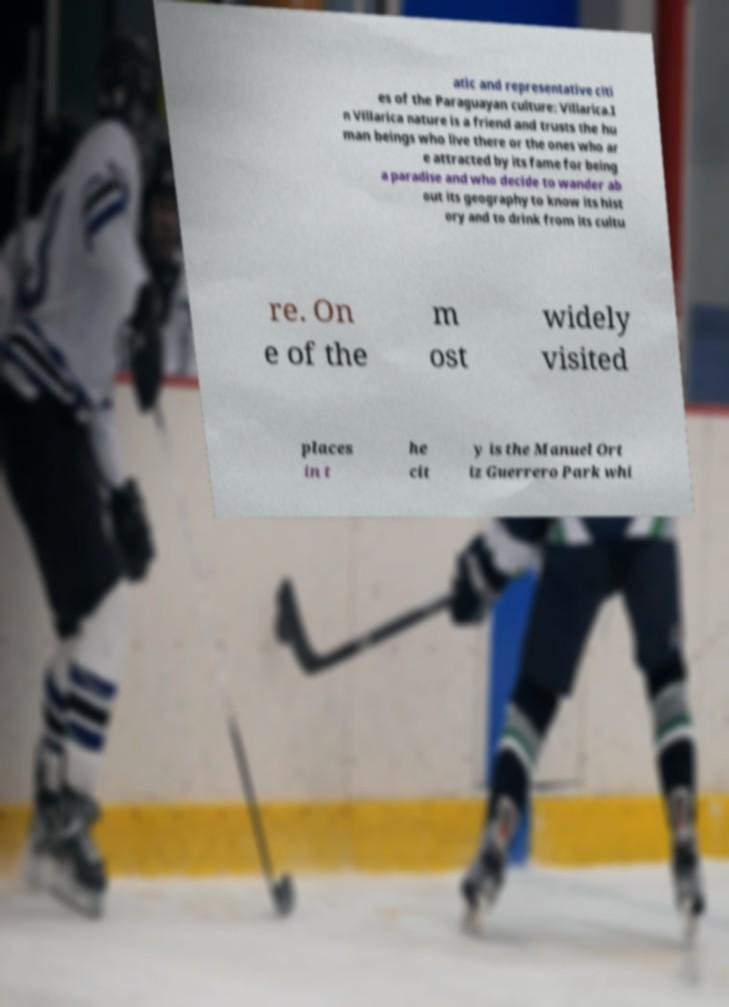For documentation purposes, I need the text within this image transcribed. Could you provide that? atic and representative citi es of the Paraguayan culture: Villarica.I n Villarica nature is a friend and trusts the hu man beings who live there or the ones who ar e attracted by its fame for being a paradise and who decide to wander ab out its geography to know its hist ory and to drink from its cultu re. On e of the m ost widely visited places in t he cit y is the Manuel Ort iz Guerrero Park whi 